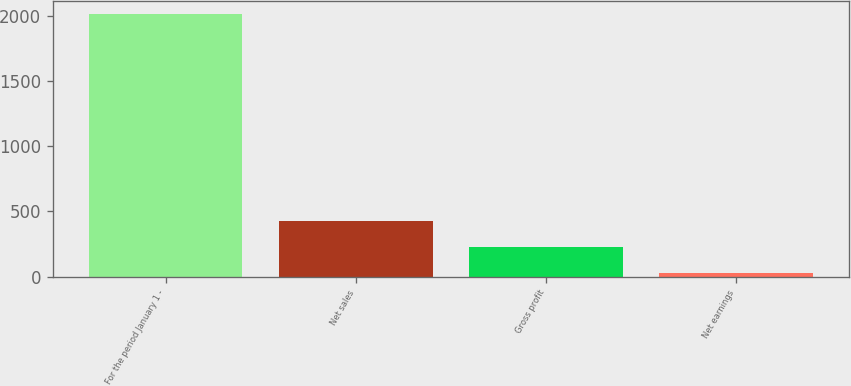<chart> <loc_0><loc_0><loc_500><loc_500><bar_chart><fcel>For the period January 1 -<fcel>Net sales<fcel>Gross profit<fcel>Net earnings<nl><fcel>2014<fcel>427.6<fcel>229.3<fcel>31<nl></chart> 